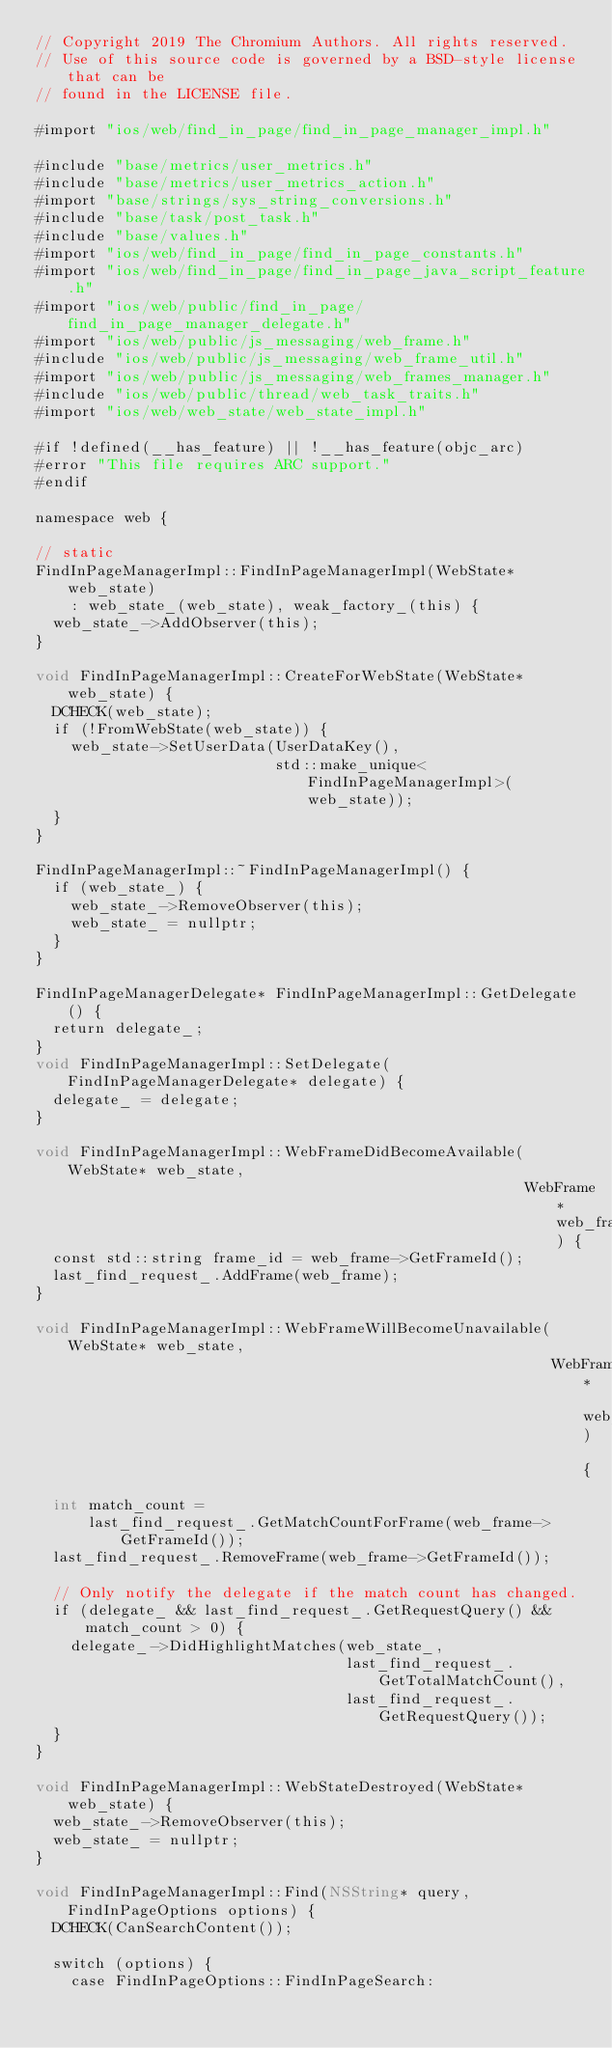<code> <loc_0><loc_0><loc_500><loc_500><_ObjectiveC_>// Copyright 2019 The Chromium Authors. All rights reserved.
// Use of this source code is governed by a BSD-style license that can be
// found in the LICENSE file.

#import "ios/web/find_in_page/find_in_page_manager_impl.h"

#include "base/metrics/user_metrics.h"
#include "base/metrics/user_metrics_action.h"
#import "base/strings/sys_string_conversions.h"
#include "base/task/post_task.h"
#include "base/values.h"
#import "ios/web/find_in_page/find_in_page_constants.h"
#import "ios/web/find_in_page/find_in_page_java_script_feature.h"
#import "ios/web/public/find_in_page/find_in_page_manager_delegate.h"
#import "ios/web/public/js_messaging/web_frame.h"
#include "ios/web/public/js_messaging/web_frame_util.h"
#import "ios/web/public/js_messaging/web_frames_manager.h"
#include "ios/web/public/thread/web_task_traits.h"
#import "ios/web/web_state/web_state_impl.h"

#if !defined(__has_feature) || !__has_feature(objc_arc)
#error "This file requires ARC support."
#endif

namespace web {

// static
FindInPageManagerImpl::FindInPageManagerImpl(WebState* web_state)
    : web_state_(web_state), weak_factory_(this) {
  web_state_->AddObserver(this);
}

void FindInPageManagerImpl::CreateForWebState(WebState* web_state) {
  DCHECK(web_state);
  if (!FromWebState(web_state)) {
    web_state->SetUserData(UserDataKey(),
                           std::make_unique<FindInPageManagerImpl>(web_state));
  }
}

FindInPageManagerImpl::~FindInPageManagerImpl() {
  if (web_state_) {
    web_state_->RemoveObserver(this);
    web_state_ = nullptr;
  }
}

FindInPageManagerDelegate* FindInPageManagerImpl::GetDelegate() {
  return delegate_;
}
void FindInPageManagerImpl::SetDelegate(FindInPageManagerDelegate* delegate) {
  delegate_ = delegate;
}

void FindInPageManagerImpl::WebFrameDidBecomeAvailable(WebState* web_state,
                                                       WebFrame* web_frame) {
  const std::string frame_id = web_frame->GetFrameId();
  last_find_request_.AddFrame(web_frame);
}

void FindInPageManagerImpl::WebFrameWillBecomeUnavailable(WebState* web_state,
                                                          WebFrame* web_frame) {
  int match_count =
      last_find_request_.GetMatchCountForFrame(web_frame->GetFrameId());
  last_find_request_.RemoveFrame(web_frame->GetFrameId());

  // Only notify the delegate if the match count has changed.
  if (delegate_ && last_find_request_.GetRequestQuery() && match_count > 0) {
    delegate_->DidHighlightMatches(web_state_,
                                   last_find_request_.GetTotalMatchCount(),
                                   last_find_request_.GetRequestQuery());
  }
}

void FindInPageManagerImpl::WebStateDestroyed(WebState* web_state) {
  web_state_->RemoveObserver(this);
  web_state_ = nullptr;
}

void FindInPageManagerImpl::Find(NSString* query, FindInPageOptions options) {
  DCHECK(CanSearchContent());

  switch (options) {
    case FindInPageOptions::FindInPageSearch:</code> 